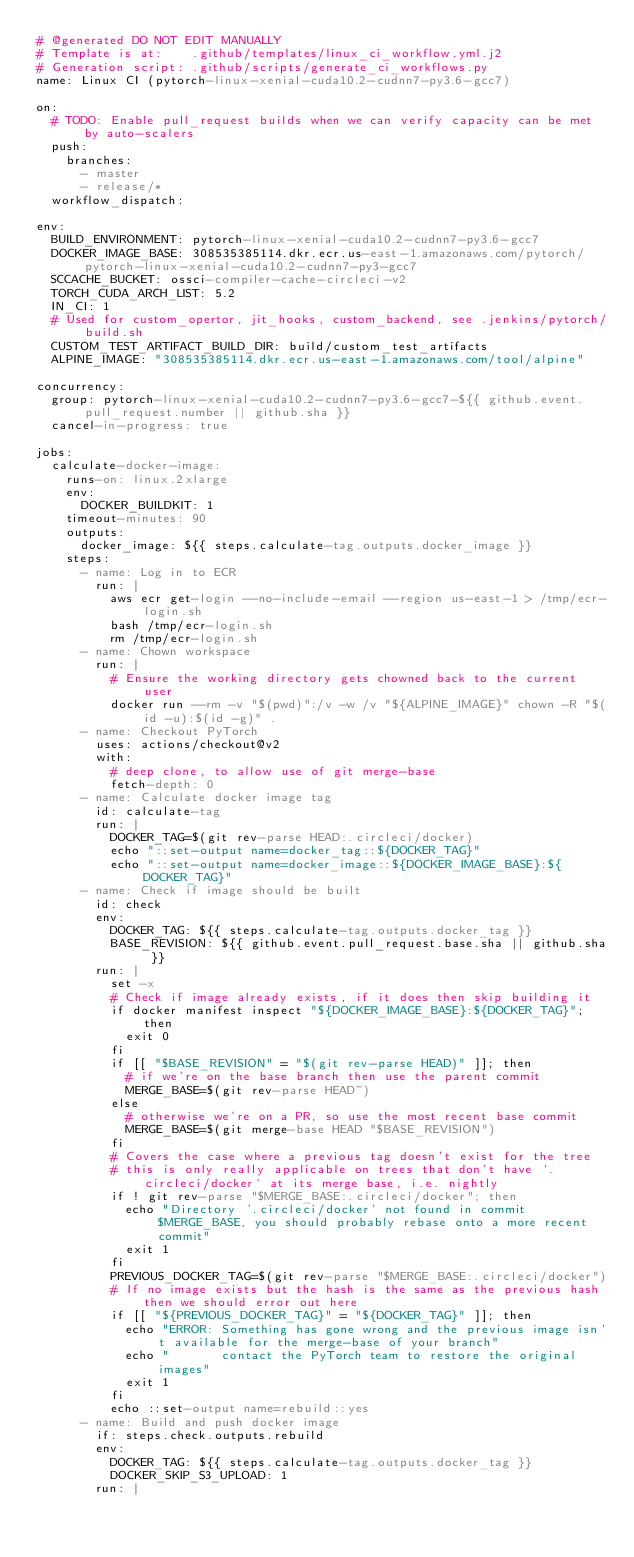Convert code to text. <code><loc_0><loc_0><loc_500><loc_500><_YAML_># @generated DO NOT EDIT MANUALLY
# Template is at:    .github/templates/linux_ci_workflow.yml.j2
# Generation script: .github/scripts/generate_ci_workflows.py
name: Linux CI (pytorch-linux-xenial-cuda10.2-cudnn7-py3.6-gcc7)

on:
  # TODO: Enable pull_request builds when we can verify capacity can be met by auto-scalers
  push:
    branches:
      - master
      - release/*
  workflow_dispatch:

env:
  BUILD_ENVIRONMENT: pytorch-linux-xenial-cuda10.2-cudnn7-py3.6-gcc7
  DOCKER_IMAGE_BASE: 308535385114.dkr.ecr.us-east-1.amazonaws.com/pytorch/pytorch-linux-xenial-cuda10.2-cudnn7-py3-gcc7
  SCCACHE_BUCKET: ossci-compiler-cache-circleci-v2
  TORCH_CUDA_ARCH_LIST: 5.2
  IN_CI: 1
  # Used for custom_opertor, jit_hooks, custom_backend, see .jenkins/pytorch/build.sh
  CUSTOM_TEST_ARTIFACT_BUILD_DIR: build/custom_test_artifacts
  ALPINE_IMAGE: "308535385114.dkr.ecr.us-east-1.amazonaws.com/tool/alpine"

concurrency:
  group: pytorch-linux-xenial-cuda10.2-cudnn7-py3.6-gcc7-${{ github.event.pull_request.number || github.sha }}
  cancel-in-progress: true

jobs:
  calculate-docker-image:
    runs-on: linux.2xlarge
    env:
      DOCKER_BUILDKIT: 1
    timeout-minutes: 90
    outputs:
      docker_image: ${{ steps.calculate-tag.outputs.docker_image }}
    steps:
      - name: Log in to ECR
        run: |
          aws ecr get-login --no-include-email --region us-east-1 > /tmp/ecr-login.sh
          bash /tmp/ecr-login.sh
          rm /tmp/ecr-login.sh
      - name: Chown workspace
        run: |
          # Ensure the working directory gets chowned back to the current user
          docker run --rm -v "$(pwd)":/v -w /v "${ALPINE_IMAGE}" chown -R "$(id -u):$(id -g)" .
      - name: Checkout PyTorch
        uses: actions/checkout@v2
        with:
          # deep clone, to allow use of git merge-base
          fetch-depth: 0
      - name: Calculate docker image tag
        id: calculate-tag
        run: |
          DOCKER_TAG=$(git rev-parse HEAD:.circleci/docker)
          echo "::set-output name=docker_tag::${DOCKER_TAG}"
          echo "::set-output name=docker_image::${DOCKER_IMAGE_BASE}:${DOCKER_TAG}"
      - name: Check if image should be built
        id: check
        env:
          DOCKER_TAG: ${{ steps.calculate-tag.outputs.docker_tag }}
          BASE_REVISION: ${{ github.event.pull_request.base.sha || github.sha }}
        run: |
          set -x
          # Check if image already exists, if it does then skip building it
          if docker manifest inspect "${DOCKER_IMAGE_BASE}:${DOCKER_TAG}"; then
            exit 0
          fi
          if [[ "$BASE_REVISION" = "$(git rev-parse HEAD)" ]]; then
            # if we're on the base branch then use the parent commit
            MERGE_BASE=$(git rev-parse HEAD~)
          else
            # otherwise we're on a PR, so use the most recent base commit
            MERGE_BASE=$(git merge-base HEAD "$BASE_REVISION")
          fi
          # Covers the case where a previous tag doesn't exist for the tree
          # this is only really applicable on trees that don't have `.circleci/docker` at its merge base, i.e. nightly
          if ! git rev-parse "$MERGE_BASE:.circleci/docker"; then
            echo "Directory '.circleci/docker' not found in commit $MERGE_BASE, you should probably rebase onto a more recent commit"
            exit 1
          fi
          PREVIOUS_DOCKER_TAG=$(git rev-parse "$MERGE_BASE:.circleci/docker")
          # If no image exists but the hash is the same as the previous hash then we should error out here
          if [[ "${PREVIOUS_DOCKER_TAG}" = "${DOCKER_TAG}" ]]; then
            echo "ERROR: Something has gone wrong and the previous image isn't available for the merge-base of your branch"
            echo "       contact the PyTorch team to restore the original images"
            exit 1
          fi
          echo ::set-output name=rebuild::yes
      - name: Build and push docker image
        if: steps.check.outputs.rebuild
        env:
          DOCKER_TAG: ${{ steps.calculate-tag.outputs.docker_tag }}
          DOCKER_SKIP_S3_UPLOAD: 1
        run: |</code> 